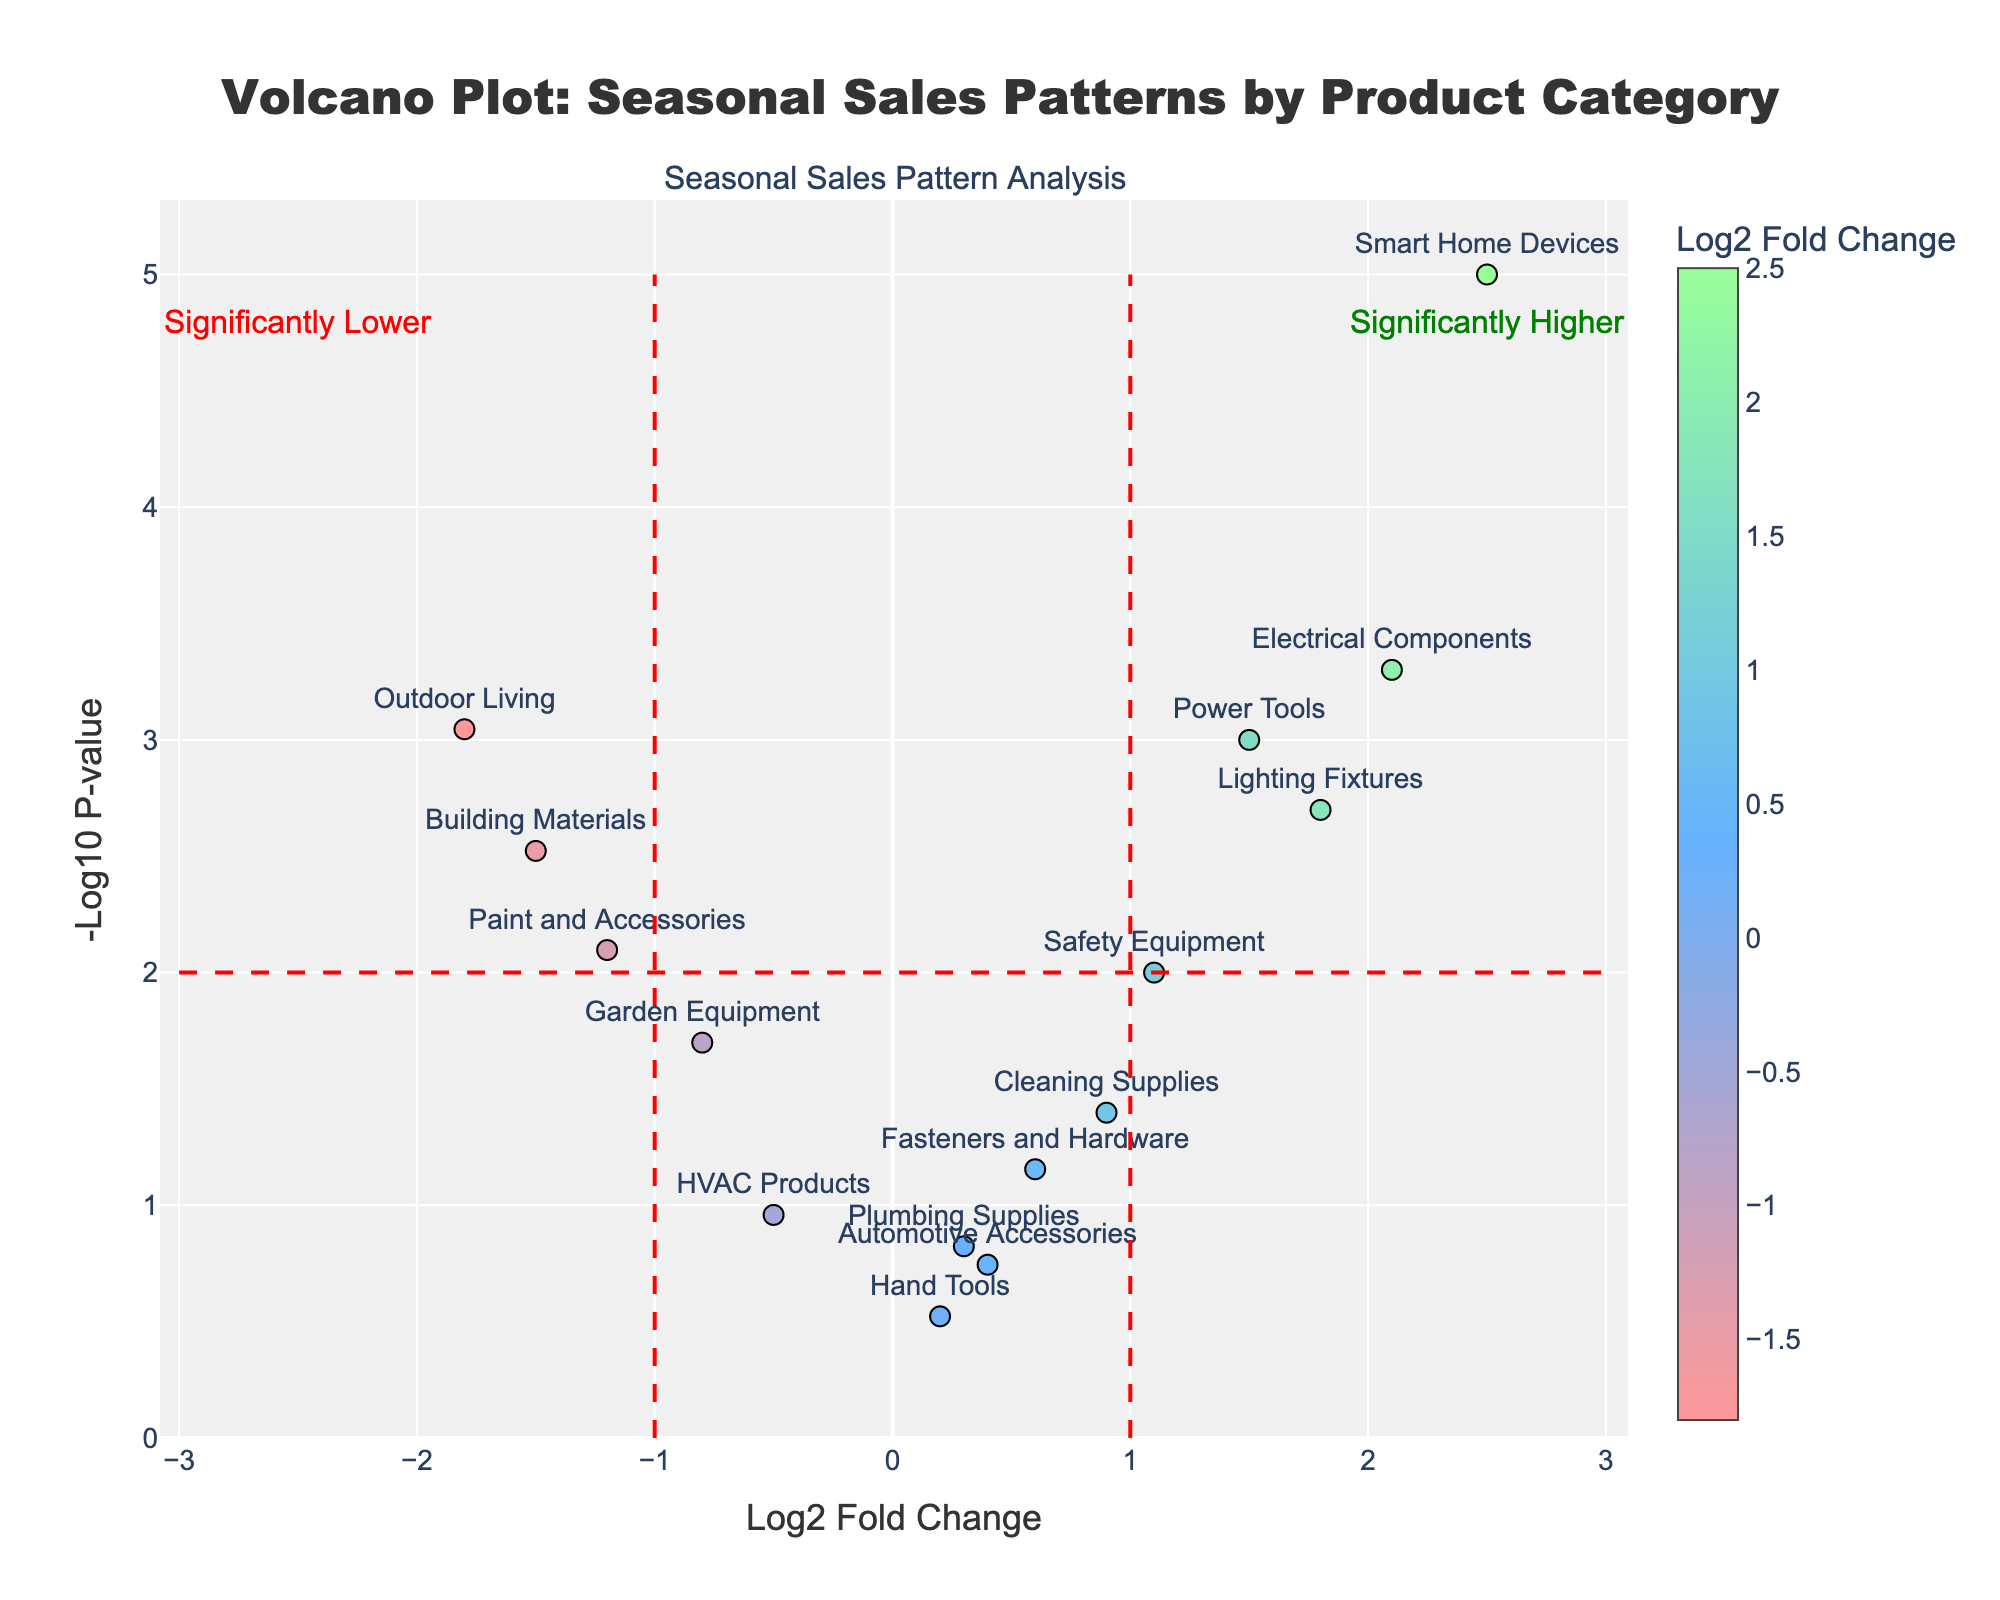What's the title of the figure? The title is the text at the very top of the plot. Here, it reads "Volcano Plot: Seasonal Sales Patterns by Product Category".
Answer: Volcano Plot: Seasonal Sales Patterns by Product Category What does the x-axis represent? The x-axis is labeled and typically represents the log2 fold change of each product category's sales pattern in a volcano plot.
Answer: Log2 Fold Change What product category has the highest log2 fold change? By identifying the data point farthest to the right on the x-axis, we can see it corresponds to "Smart Home Devices".
Answer: Smart Home Devices Which product category has the lowest p-value? The p-value is represented on the y-axis as -log10(p-value). A lower p-value means a higher value on the y-axis. The highest point on the y-axis corresponds to "Smart Home Devices".
Answer: Smart Home Devices How many product categories have a negative log2 fold change? Negative log2 fold changes are represented on the left side of the x-axis. Counting these points gives us 5 categories: "Garden Equipment", "Paint and Accessories", "Building Materials", "HVAC Products", and "Outdoor Living".
Answer: 5 Which categories show significantly higher sales patterns? Significantly higher sales patterns are indicated by data points to the right of the x=1 threshold line and above the y=2 threshold line. The affected categories are "Power Tools", "Electrical Components", "Lighting Fixtures", "Safety Equipment", and "Smart Home Devices".
Answer: Power Tools, Electrical Components, Lighting Fixtures, Safety Equipment, Smart Home Devices Which category has a notable fold change but is not statistically significant? Noting a product with a visible but not statistically significant change means looking for lower height on the y-axis but positioned away from the zero on the x-axis. "Fasteners and Hardware" fits this, given its intermediate positions.
Answer: Fasteners and Hardware What general trend can be observed for product categories with negative log2 fold changes? Observing the left side of the x-axis for general behavior, we see that products with negative log2 fold changes often indicate a decline in sales. the majority appearing below the y=2 threshold line indicating a lack of strong statistical significance.
Answer: Declining sales trend (and mostly not statistically significant) For "Outdoor Living," what can you infer about its sales pattern and significance? "Outdoor Living" is far left on the x-axis and above the y=2 threshold, indicating a significant decrease in sales pattern based on its negative log2 fold change and low p-value.
Answer: Significant decrease in sales pattern 